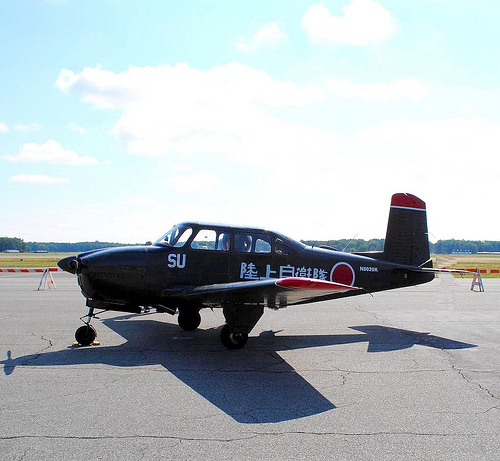How would you enhance the historical significance of this aircraft through an exhibition? To enhance the historical significance of this aircraft, I would create an interactive exhibition featuring augmented reality displays of its history and role in aviation. Visitors could sit in a replica cockpit and experience a simulated flight training session. Additionally, personal stories from pilots who trained on this plane, along with historical footage and photographs, would be showcased to provide a richer context and a deeper appreciation for the aircraft's legacy. Imagine a child's dream after seeing this plane at an exhibition. How may it look like? 'In their dream, the child finds themselves in the cockpit of the plane, lifting off the runway and soaring towards the clouds. As they navigate the skies, they perform acrobatic maneuvers, weaving through picturesque cumulus clouds, and even encountering whimsical elements like a flock of rainbow-colored birds or playful skywriting balloons. The dream culminates in a heroic landing, greeted with applause from an enchanted crowd on the ground, fostering a newfound love for aviation and adventure.' 